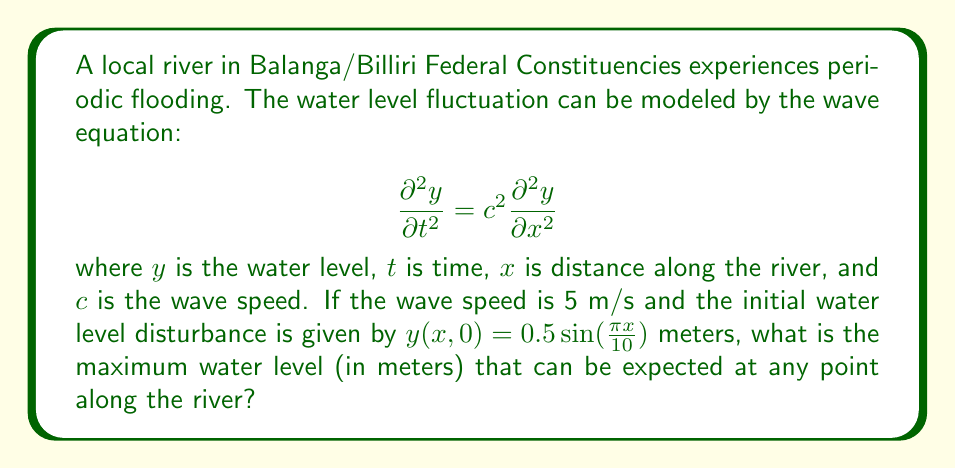Give your solution to this math problem. To solve this problem, we need to analyze the given wave equation and initial condition:

1) The general solution to the 1D wave equation is:
   $$y(x,t) = f(x-ct) + g(x+ct)$$
   where $f$ and $g$ are arbitrary functions.

2) Given the initial condition $y(x,0) = 0.5\sin(\frac{\pi x}{10})$, we can deduce that the solution will take the form:
   $$y(x,t) = 0.25\sin(\frac{\pi(x-ct)}{10}) + 0.25\sin(\frac{\pi(x+ct)}{10})$$

3) Using the trigonometric identity for the sum of sines:
   $$\sin A + \sin B = 2\sin(\frac{A+B}{2})\cos(\frac{A-B}{2})$$

4) Applying this to our solution:
   $$y(x,t) = 0.5\sin(\frac{\pi x}{10})\cos(\frac{\pi ct}{10})$$

5) The maximum amplitude of this wave will occur when both $\sin(\frac{\pi x}{10})$ and $\cos(\frac{\pi ct}{10})$ are at their maximum values of 1 or -1.

6) Therefore, the maximum water level at any point along the river will be:
   $$y_{max} = 0.5 \cdot 1 \cdot 1 = 0.5\text{ meters}$$

This maximum occurs periodically in both space and time.
Answer: 0.5 meters 